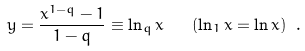<formula> <loc_0><loc_0><loc_500><loc_500>y = \frac { x ^ { 1 - q } - 1 } { 1 - q } \equiv \ln _ { q } x \quad ( \ln _ { 1 } x = \ln x ) \ .</formula> 